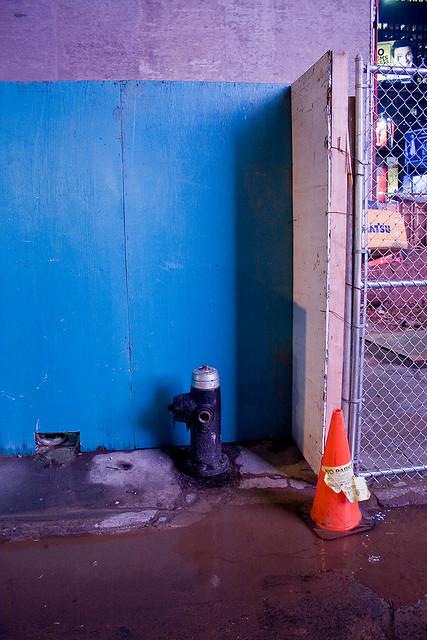Where is the cone?
Concise answer only. On top of gnome head. Is the wall blue?
Keep it brief. Yes. Is there water on the ground?
Answer briefly. Yes. 